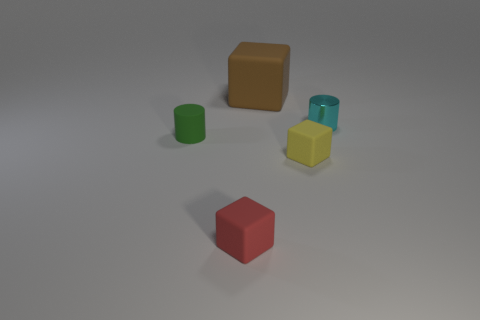What number of tiny red blocks are right of the tiny cube that is in front of the yellow cube?
Keep it short and to the point. 0. Are there more small cyan shiny cylinders that are behind the tiny shiny thing than small yellow blocks?
Provide a short and direct response. No. There is a matte thing that is in front of the small cyan cylinder and behind the tiny yellow matte cube; what size is it?
Make the answer very short. Small. There is a tiny object that is both on the right side of the big object and in front of the small cyan thing; what is its shape?
Your answer should be very brief. Cube. Are there any tiny blocks behind the cylinder that is in front of the small cylinder on the right side of the green rubber object?
Give a very brief answer. No. How many objects are either blocks behind the tiny yellow block or cubes in front of the yellow object?
Your response must be concise. 2. Is the material of the object that is to the right of the tiny yellow thing the same as the large cube?
Ensure brevity in your answer.  No. There is a cube that is right of the small red rubber cube and in front of the small cyan metal cylinder; what material is it?
Offer a terse response. Rubber. What is the color of the thing that is behind the cylinder right of the rubber cylinder?
Your answer should be very brief. Brown. What material is the other thing that is the same shape as the small shiny thing?
Offer a very short reply. Rubber. 